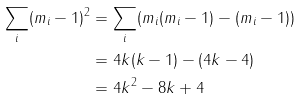<formula> <loc_0><loc_0><loc_500><loc_500>\sum _ { i } ( m _ { i } - 1 ) ^ { 2 } & = \sum _ { i } ( m _ { i } ( m _ { i } - 1 ) - ( m _ { i } - 1 ) ) \\ & = 4 k ( k - 1 ) - ( 4 k - 4 ) \\ & = 4 k ^ { 2 } - 8 k + 4</formula> 